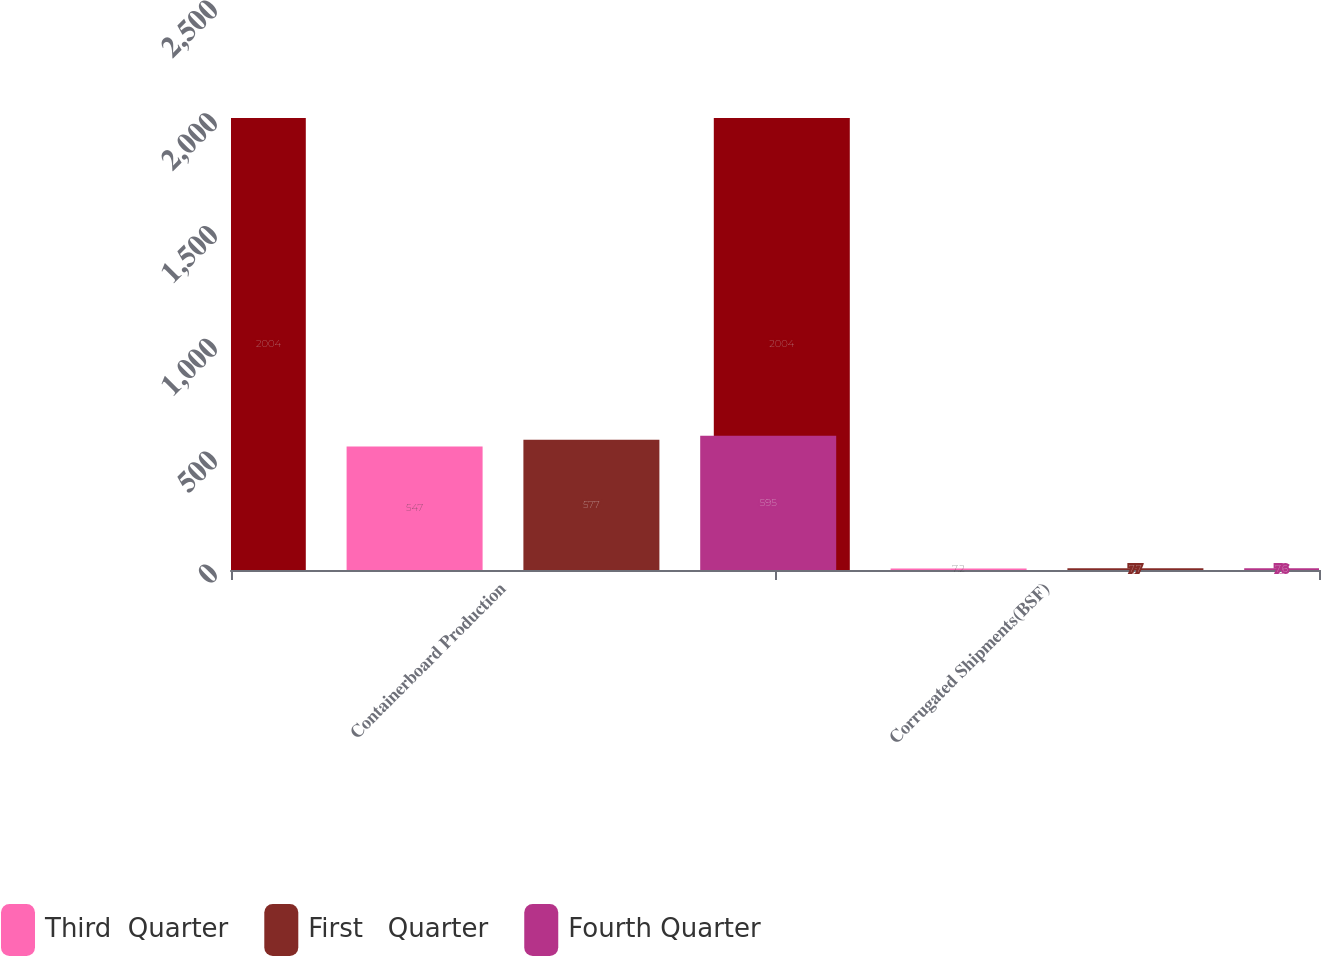<chart> <loc_0><loc_0><loc_500><loc_500><stacked_bar_chart><ecel><fcel>Containerboard Production<fcel>Corrugated Shipments(BSF)<nl><fcel>nan<fcel>2004<fcel>2004<nl><fcel>Third  Quarter<fcel>547<fcel>7.2<nl><fcel>First   Quarter<fcel>577<fcel>7.7<nl><fcel>Fourth Quarter<fcel>595<fcel>7.6<nl></chart> 